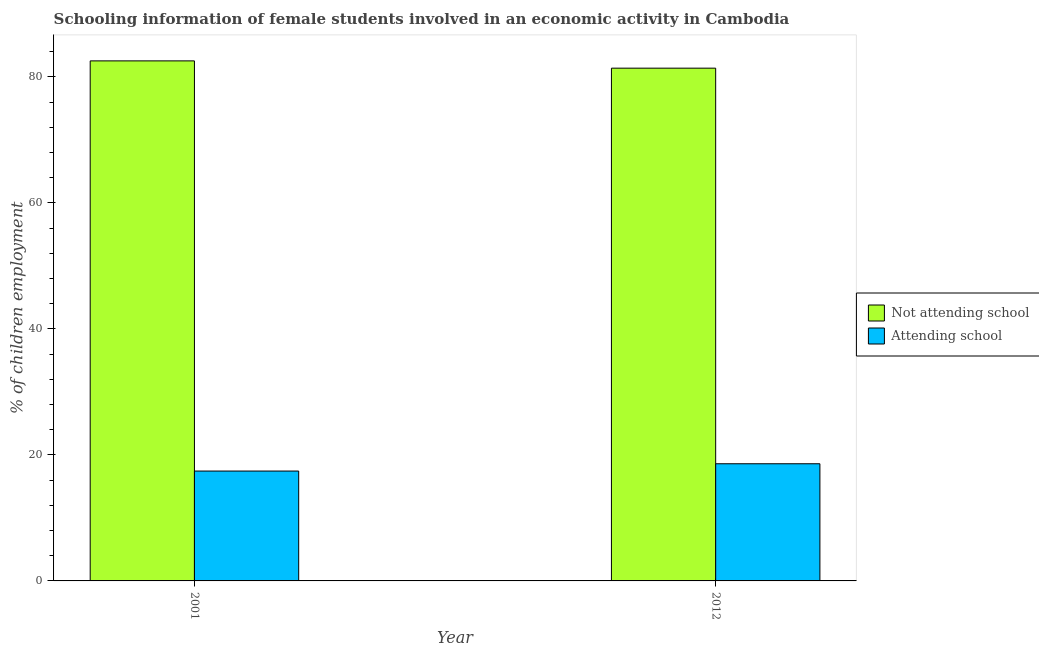Are the number of bars per tick equal to the number of legend labels?
Provide a succinct answer. Yes. Are the number of bars on each tick of the X-axis equal?
Make the answer very short. Yes. What is the label of the 1st group of bars from the left?
Offer a very short reply. 2001. What is the percentage of employed females who are not attending school in 2012?
Provide a short and direct response. 81.4. Across all years, what is the maximum percentage of employed females who are attending school?
Provide a succinct answer. 18.6. Across all years, what is the minimum percentage of employed females who are attending school?
Your answer should be compact. 17.44. In which year was the percentage of employed females who are not attending school maximum?
Ensure brevity in your answer.  2001. What is the total percentage of employed females who are not attending school in the graph?
Provide a short and direct response. 163.96. What is the difference between the percentage of employed females who are not attending school in 2001 and that in 2012?
Your answer should be compact. 1.16. What is the difference between the percentage of employed females who are not attending school in 2001 and the percentage of employed females who are attending school in 2012?
Your answer should be compact. 1.16. What is the average percentage of employed females who are attending school per year?
Provide a short and direct response. 18.02. What is the ratio of the percentage of employed females who are attending school in 2001 to that in 2012?
Keep it short and to the point. 0.94. What does the 2nd bar from the left in 2001 represents?
Provide a succinct answer. Attending school. What does the 2nd bar from the right in 2012 represents?
Offer a very short reply. Not attending school. How many bars are there?
Offer a terse response. 4. Are all the bars in the graph horizontal?
Ensure brevity in your answer.  No. How many years are there in the graph?
Your response must be concise. 2. How are the legend labels stacked?
Make the answer very short. Vertical. What is the title of the graph?
Make the answer very short. Schooling information of female students involved in an economic activity in Cambodia. What is the label or title of the X-axis?
Your response must be concise. Year. What is the label or title of the Y-axis?
Make the answer very short. % of children employment. What is the % of children employment of Not attending school in 2001?
Provide a succinct answer. 82.56. What is the % of children employment of Attending school in 2001?
Offer a very short reply. 17.44. What is the % of children employment of Not attending school in 2012?
Provide a short and direct response. 81.4. What is the % of children employment in Attending school in 2012?
Offer a terse response. 18.6. Across all years, what is the maximum % of children employment in Not attending school?
Offer a very short reply. 82.56. Across all years, what is the minimum % of children employment of Not attending school?
Offer a very short reply. 81.4. Across all years, what is the minimum % of children employment in Attending school?
Your response must be concise. 17.44. What is the total % of children employment in Not attending school in the graph?
Make the answer very short. 163.96. What is the total % of children employment of Attending school in the graph?
Provide a succinct answer. 36.04. What is the difference between the % of children employment in Not attending school in 2001 and that in 2012?
Offer a very short reply. 1.16. What is the difference between the % of children employment of Attending school in 2001 and that in 2012?
Your response must be concise. -1.16. What is the difference between the % of children employment in Not attending school in 2001 and the % of children employment in Attending school in 2012?
Your response must be concise. 63.96. What is the average % of children employment in Not attending school per year?
Your response must be concise. 81.98. What is the average % of children employment of Attending school per year?
Your answer should be compact. 18.02. In the year 2001, what is the difference between the % of children employment in Not attending school and % of children employment in Attending school?
Offer a terse response. 65.12. In the year 2012, what is the difference between the % of children employment in Not attending school and % of children employment in Attending school?
Your answer should be very brief. 62.8. What is the ratio of the % of children employment of Not attending school in 2001 to that in 2012?
Offer a very short reply. 1.01. What is the ratio of the % of children employment of Attending school in 2001 to that in 2012?
Your response must be concise. 0.94. What is the difference between the highest and the second highest % of children employment in Not attending school?
Your answer should be compact. 1.16. What is the difference between the highest and the second highest % of children employment of Attending school?
Make the answer very short. 1.16. What is the difference between the highest and the lowest % of children employment of Not attending school?
Your response must be concise. 1.16. What is the difference between the highest and the lowest % of children employment in Attending school?
Ensure brevity in your answer.  1.16. 